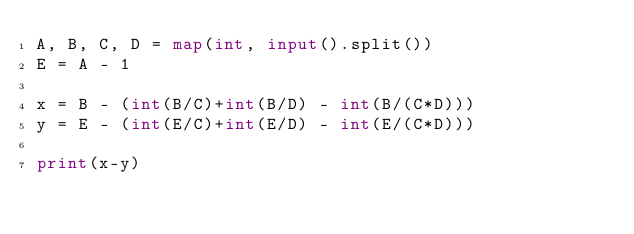Convert code to text. <code><loc_0><loc_0><loc_500><loc_500><_Python_>A, B, C, D = map(int, input().split())
E = A - 1

x = B - (int(B/C)+int(B/D) - int(B/(C*D)))
y = E - (int(E/C)+int(E/D) - int(E/(C*D)))

print(x-y)</code> 